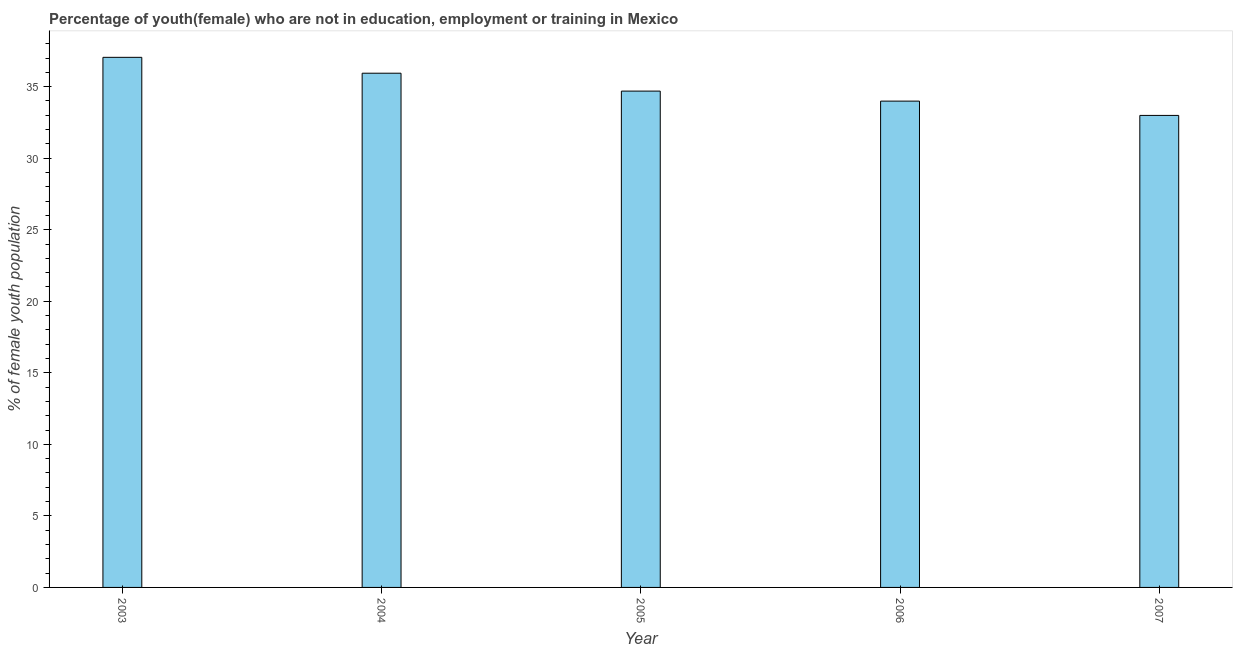Does the graph contain any zero values?
Give a very brief answer. No. What is the title of the graph?
Keep it short and to the point. Percentage of youth(female) who are not in education, employment or training in Mexico. What is the label or title of the X-axis?
Your answer should be very brief. Year. What is the label or title of the Y-axis?
Your answer should be very brief. % of female youth population. What is the unemployed female youth population in 2003?
Provide a succinct answer. 37.05. Across all years, what is the maximum unemployed female youth population?
Offer a terse response. 37.05. Across all years, what is the minimum unemployed female youth population?
Give a very brief answer. 32.99. In which year was the unemployed female youth population maximum?
Make the answer very short. 2003. In which year was the unemployed female youth population minimum?
Offer a very short reply. 2007. What is the sum of the unemployed female youth population?
Offer a very short reply. 174.66. What is the difference between the unemployed female youth population in 2004 and 2006?
Keep it short and to the point. 1.95. What is the average unemployed female youth population per year?
Keep it short and to the point. 34.93. What is the median unemployed female youth population?
Ensure brevity in your answer.  34.69. In how many years, is the unemployed female youth population greater than 24 %?
Provide a succinct answer. 5. What is the ratio of the unemployed female youth population in 2003 to that in 2006?
Provide a succinct answer. 1.09. Is the unemployed female youth population in 2004 less than that in 2007?
Offer a very short reply. No. What is the difference between the highest and the second highest unemployed female youth population?
Your response must be concise. 1.11. Is the sum of the unemployed female youth population in 2004 and 2005 greater than the maximum unemployed female youth population across all years?
Give a very brief answer. Yes. What is the difference between the highest and the lowest unemployed female youth population?
Offer a terse response. 4.06. In how many years, is the unemployed female youth population greater than the average unemployed female youth population taken over all years?
Provide a succinct answer. 2. How many bars are there?
Offer a terse response. 5. Are all the bars in the graph horizontal?
Your answer should be compact. No. How many years are there in the graph?
Ensure brevity in your answer.  5. Are the values on the major ticks of Y-axis written in scientific E-notation?
Offer a very short reply. No. What is the % of female youth population in 2003?
Keep it short and to the point. 37.05. What is the % of female youth population in 2004?
Your answer should be very brief. 35.94. What is the % of female youth population in 2005?
Ensure brevity in your answer.  34.69. What is the % of female youth population of 2006?
Offer a terse response. 33.99. What is the % of female youth population of 2007?
Your answer should be compact. 32.99. What is the difference between the % of female youth population in 2003 and 2004?
Keep it short and to the point. 1.11. What is the difference between the % of female youth population in 2003 and 2005?
Your answer should be very brief. 2.36. What is the difference between the % of female youth population in 2003 and 2006?
Your response must be concise. 3.06. What is the difference between the % of female youth population in 2003 and 2007?
Provide a short and direct response. 4.06. What is the difference between the % of female youth population in 2004 and 2006?
Offer a terse response. 1.95. What is the difference between the % of female youth population in 2004 and 2007?
Provide a succinct answer. 2.95. What is the difference between the % of female youth population in 2005 and 2007?
Make the answer very short. 1.7. What is the ratio of the % of female youth population in 2003 to that in 2004?
Offer a very short reply. 1.03. What is the ratio of the % of female youth population in 2003 to that in 2005?
Your answer should be very brief. 1.07. What is the ratio of the % of female youth population in 2003 to that in 2006?
Provide a succinct answer. 1.09. What is the ratio of the % of female youth population in 2003 to that in 2007?
Keep it short and to the point. 1.12. What is the ratio of the % of female youth population in 2004 to that in 2005?
Your answer should be very brief. 1.04. What is the ratio of the % of female youth population in 2004 to that in 2006?
Keep it short and to the point. 1.06. What is the ratio of the % of female youth population in 2004 to that in 2007?
Ensure brevity in your answer.  1.09. What is the ratio of the % of female youth population in 2005 to that in 2006?
Ensure brevity in your answer.  1.02. What is the ratio of the % of female youth population in 2005 to that in 2007?
Keep it short and to the point. 1.05. What is the ratio of the % of female youth population in 2006 to that in 2007?
Keep it short and to the point. 1.03. 